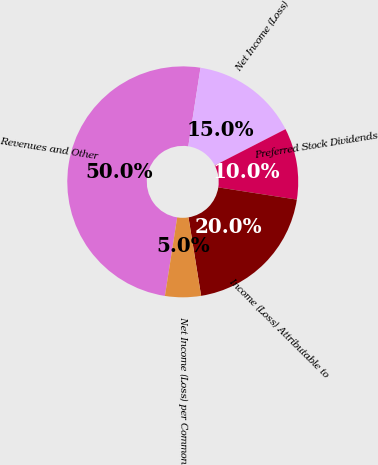Convert chart to OTSL. <chart><loc_0><loc_0><loc_500><loc_500><pie_chart><fcel>Revenues and Other<fcel>Net Income (Loss)<fcel>Preferred Stock Dividends<fcel>Income (Loss) Attributable to<fcel>Net Income (Loss) per Common<nl><fcel>49.99%<fcel>15.0%<fcel>10.0%<fcel>20.0%<fcel>5.01%<nl></chart> 